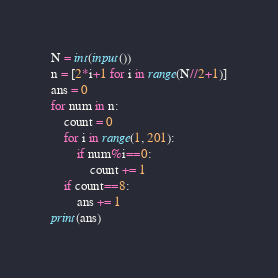Convert code to text. <code><loc_0><loc_0><loc_500><loc_500><_Python_>N = int(input())
n = [2*i+1 for i in range(N//2+1)]
ans = 0
for num in n:
    count = 0
    for i in range(1, 201):
        if num%i==0:
            count += 1
    if count==8:
        ans += 1
print(ans)</code> 